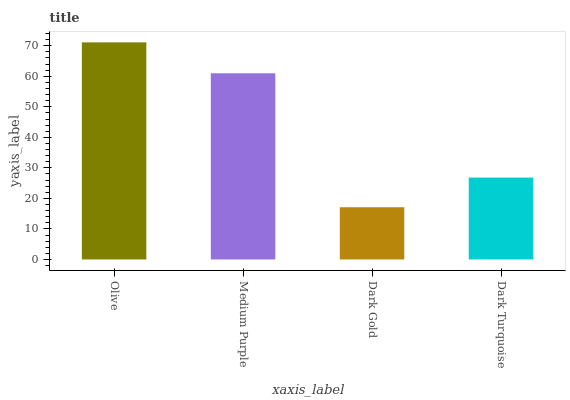Is Dark Gold the minimum?
Answer yes or no. Yes. Is Olive the maximum?
Answer yes or no. Yes. Is Medium Purple the minimum?
Answer yes or no. No. Is Medium Purple the maximum?
Answer yes or no. No. Is Olive greater than Medium Purple?
Answer yes or no. Yes. Is Medium Purple less than Olive?
Answer yes or no. Yes. Is Medium Purple greater than Olive?
Answer yes or no. No. Is Olive less than Medium Purple?
Answer yes or no. No. Is Medium Purple the high median?
Answer yes or no. Yes. Is Dark Turquoise the low median?
Answer yes or no. Yes. Is Olive the high median?
Answer yes or no. No. Is Olive the low median?
Answer yes or no. No. 